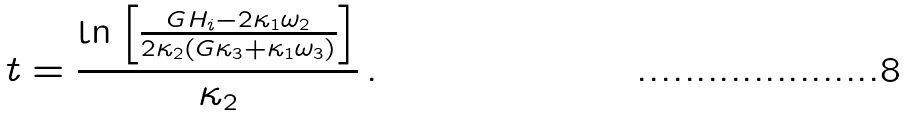<formula> <loc_0><loc_0><loc_500><loc_500>t = \frac { \ln \left [ \frac { G H _ { i } - 2 \kappa _ { 1 } \omega _ { 2 } } { 2 \kappa _ { 2 } ( G \kappa _ { 3 } + \kappa _ { 1 } \omega _ { 3 } ) } \right ] } { \kappa _ { 2 } } \, .</formula> 